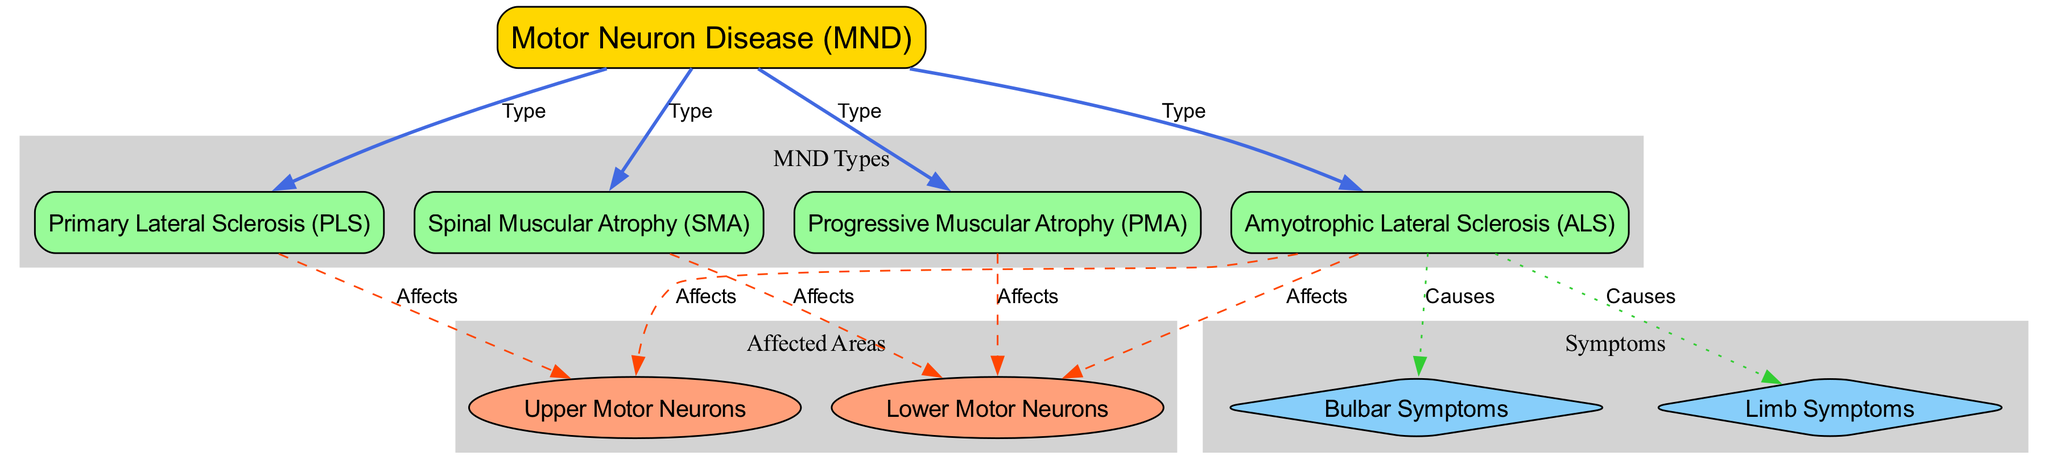What are the four main types of Motor Neuron Disease listed in the diagram? The diagram explicitly lists the four main types of Motor Neuron Disease as Amyotrophic Lateral Sclerosis (ALS), Primary Lateral Sclerosis (PLS), Progressive Muscular Atrophy (PMA), and Spinal Muscular Atrophy (SMA).
Answer: ALS, PLS, PMA, SMA How many edges connect the main type of Motor Neuron Disease to specific diseases? The diagram shows four edges that directly connect the main node "Motor Neuron Disease (MND)" to the four specific diseases, indicating the classification of MND types.
Answer: 4 Which type of Motor Neuron Disease affects both upper and lower motor neurons? The diagram indicates that Amyotrophic Lateral Sclerosis (ALS) affects both upper motor neurons and lower motor neurons, as shown by the connections to both nodes.
Answer: ALS What type of symptoms does ALS cause? The diagram illustrates that ALS causes both bulbar symptoms and limb symptoms, as evidenced by the connections from ALS to those symptom nodes.
Answer: Bulbar Symptoms, Limb Symptoms Which disease is related only to lower motor neuron affects? The diagram shows that Progressive Muscular Atrophy (PMA) and Spinal Muscular Atrophy (SMA) are both connected only to the lower motor neuron node, indicating they affect only this type of motor neuron.
Answer: PMA, SMA How many disease types can cause bulbar symptoms according to the diagram? In the diagram, only one disease type, Amyotrophic Lateral Sclerosis (ALS), is shown to cause bulbar symptoms, as it is directly connected to the bulbar symptoms node.
Answer: 1 Which symptom type is exclusively linked to the Upper Motor Neurons and not to Lower Motor Neurons in the diagram? The diagram specifies that only Primary Lateral Sclerosis (PLS) is linked to upper motor neuron affects, which shows that these symptoms are related specifically to upper motor neurons without any connection to lower motor neurons.
Answer: Upper Motor Neuron Symptoms Which two disease types affect only lower motor neurons? The diagram reveals that both Progressive Muscular Atrophy (PMA) and Spinal Muscular Atrophy (SMA) are exclusively linked to lower motor neuron affects, confirming they affect only this type.
Answer: PMA, SMA 